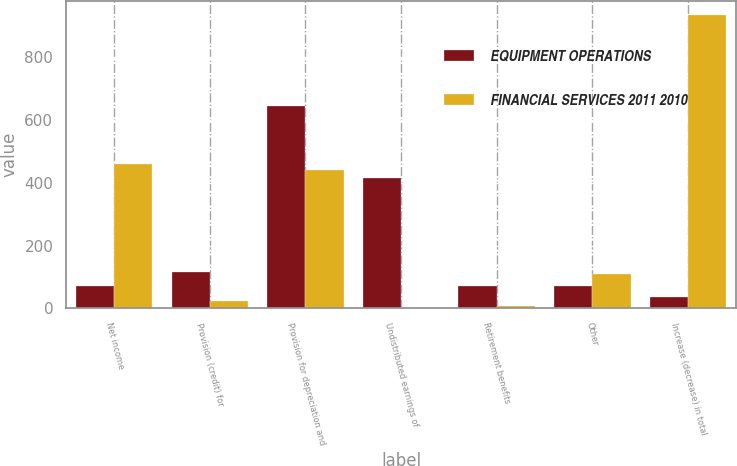Convert chart. <chart><loc_0><loc_0><loc_500><loc_500><stacked_bar_chart><ecel><fcel>Net income<fcel>Provision (credit) for<fcel>Provision for depreciation and<fcel>Undistributed earnings of<fcel>Retirement benefits<fcel>Other<fcel>Increase (decrease) in total<nl><fcel>EQUIPMENT OPERATIONS<fcel>71.2<fcel>115.7<fcel>643.1<fcel>413.7<fcel>71.2<fcel>70.5<fcel>36.4<nl><fcel>FINANCIAL SERVICES 2011 2010<fcel>460.3<fcel>23.9<fcel>439.2<fcel>1.3<fcel>7.9<fcel>109.9<fcel>931.3<nl></chart> 